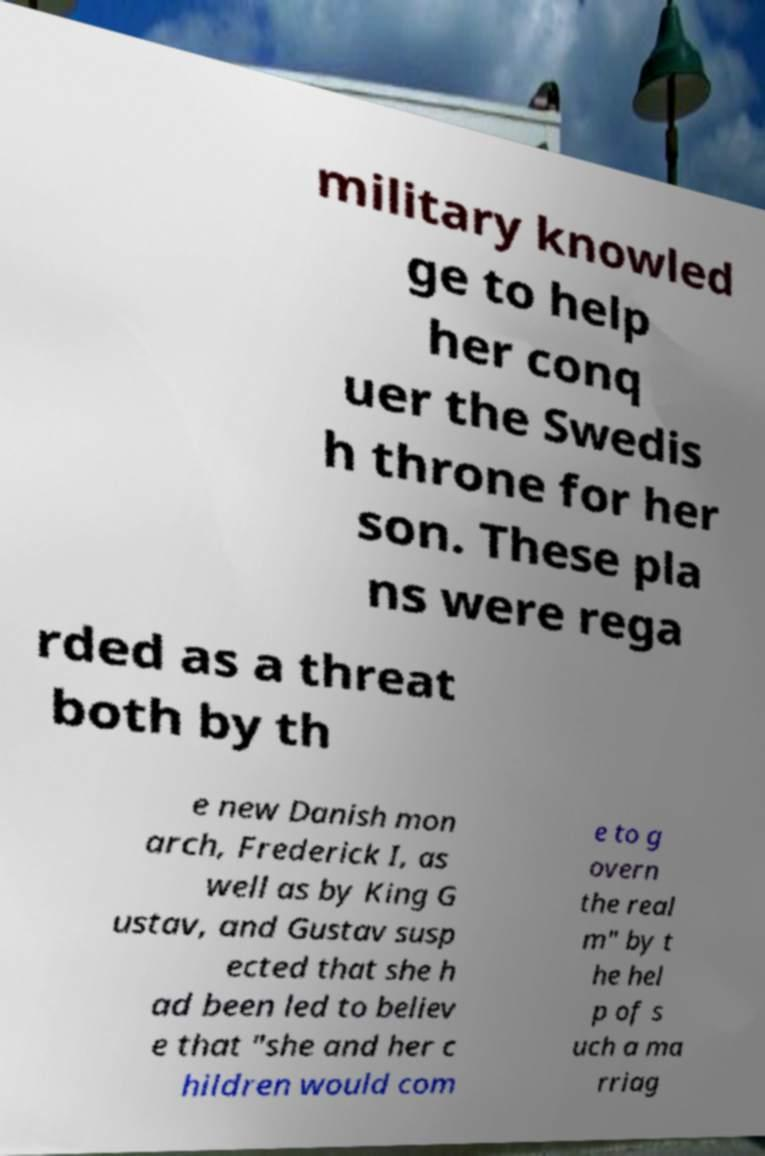Can you accurately transcribe the text from the provided image for me? military knowled ge to help her conq uer the Swedis h throne for her son. These pla ns were rega rded as a threat both by th e new Danish mon arch, Frederick I, as well as by King G ustav, and Gustav susp ected that she h ad been led to believ e that "she and her c hildren would com e to g overn the real m" by t he hel p of s uch a ma rriag 